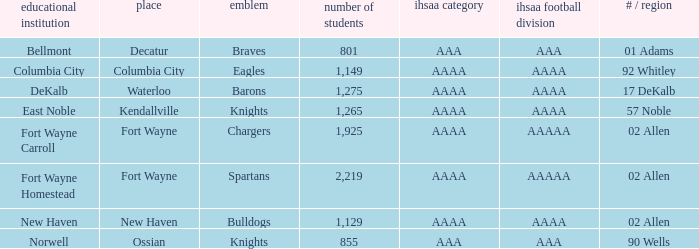What school has a mascot of the spartans with an AAAA IHSAA class and more than 1,275 enrolled? Fort Wayne Homestead. 